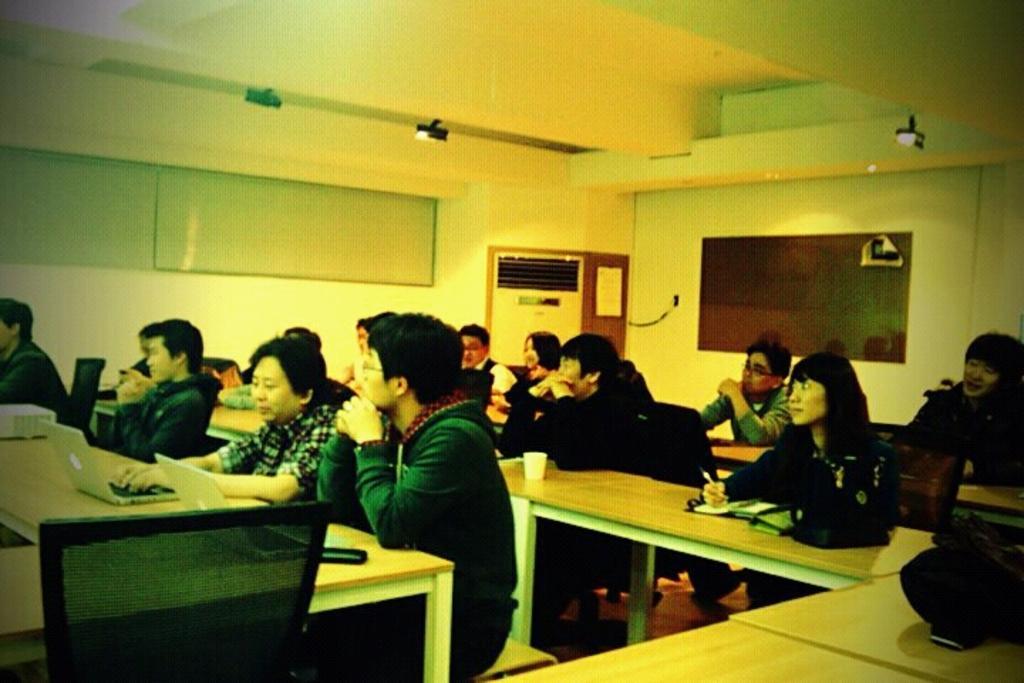Could you give a brief overview of what you see in this image? A group of people are sitting in the benches and working in their laptops. 